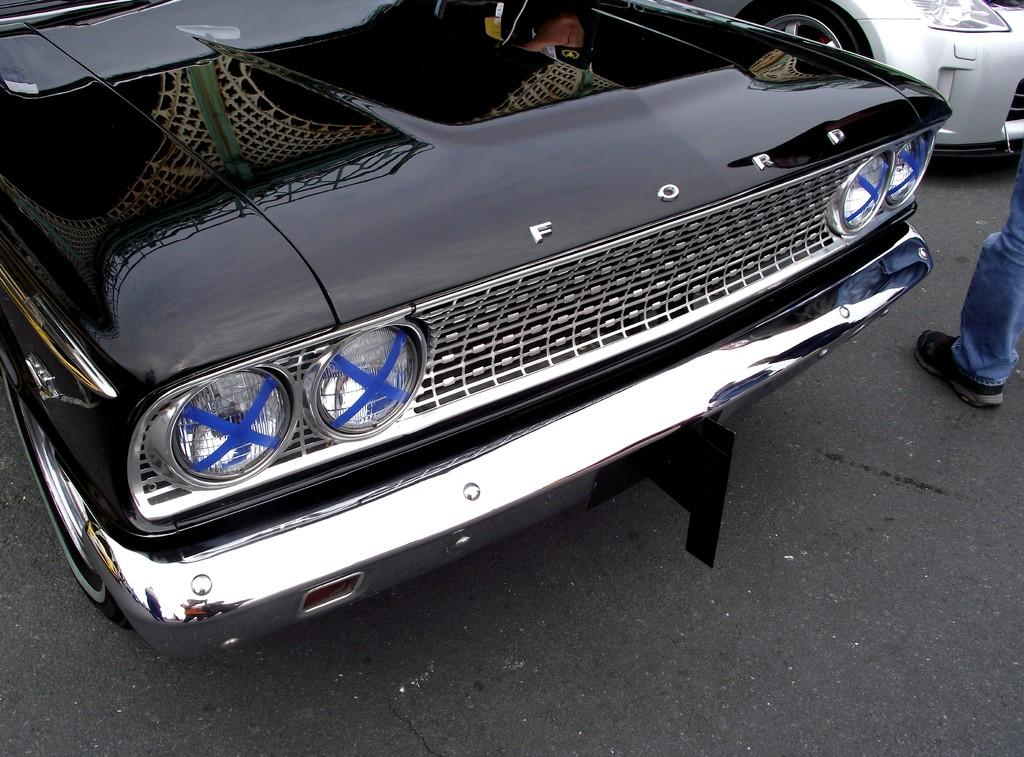What is at the bottom of the image? There is a road at the bottom of the image. What is happening on the road? Cars are present on the road. Can you describe anything on the right side of the image? A person's leg is visible on the right side of the image. How many eyes can be seen in the image? There are no eyes visible in the image. 